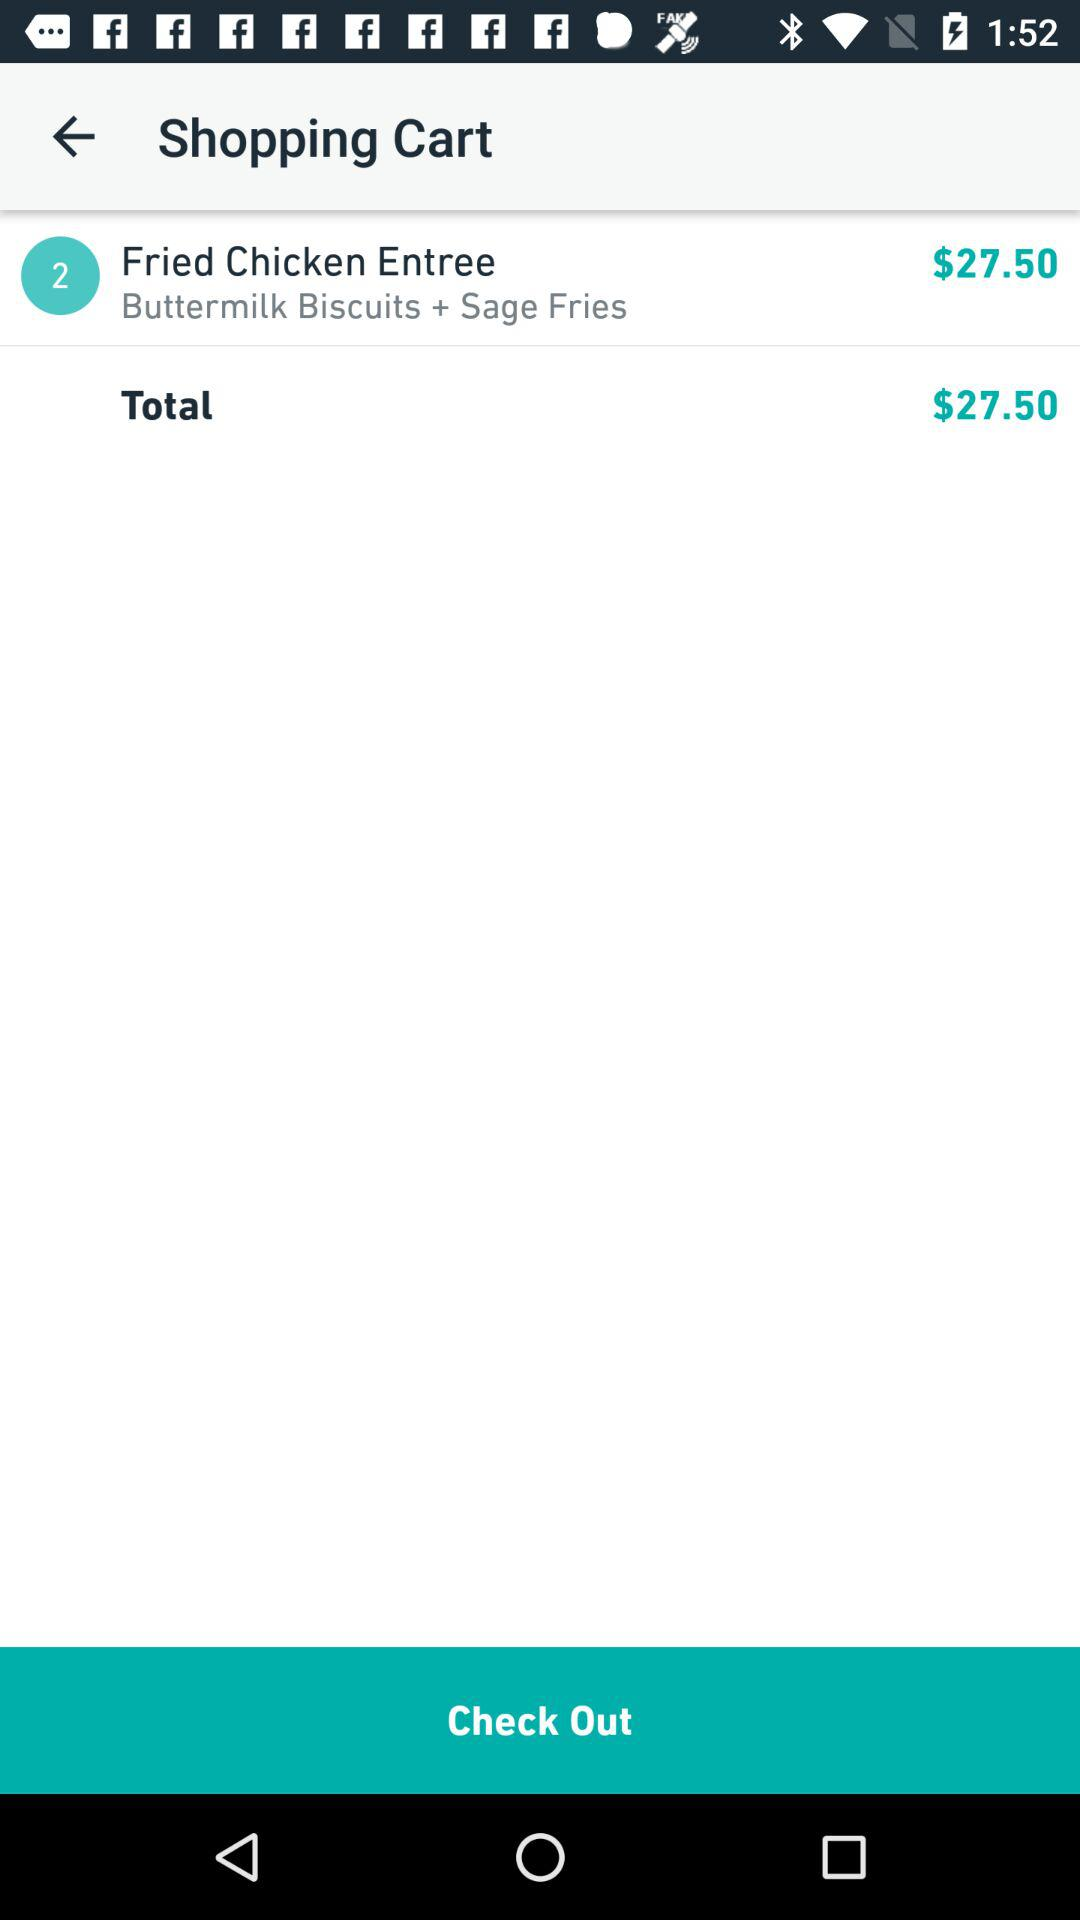What is the total price? The total price is $27.50. 